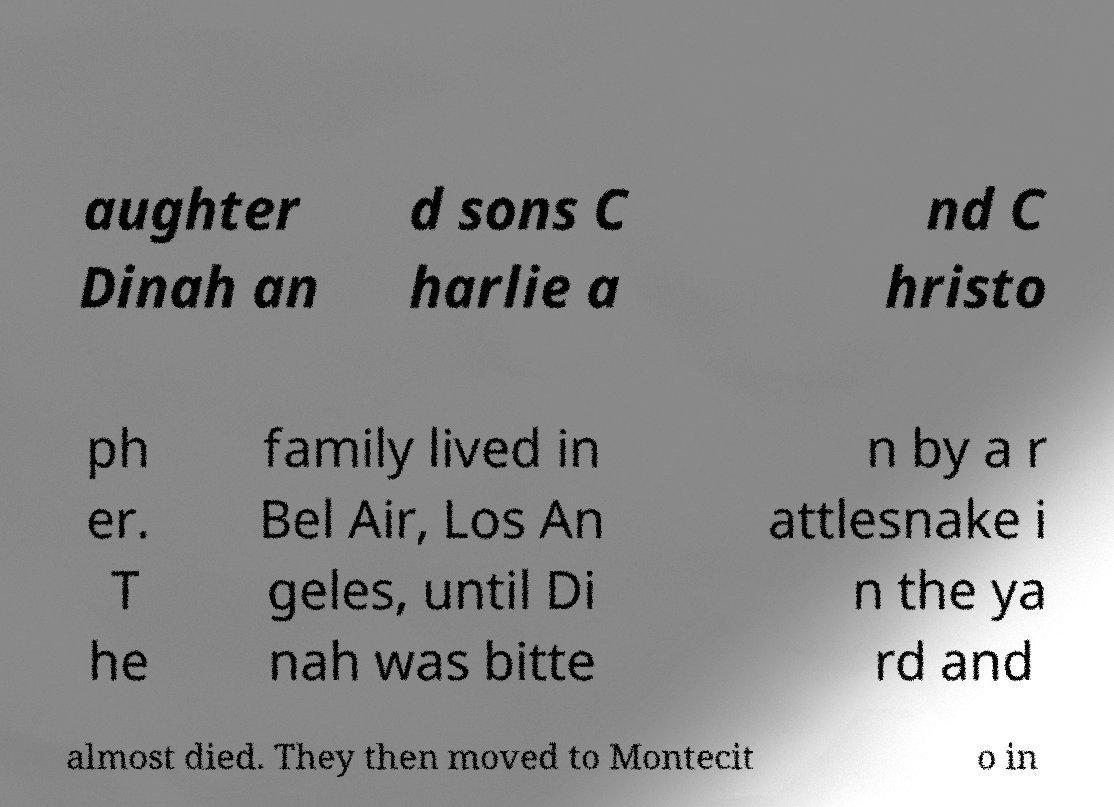There's text embedded in this image that I need extracted. Can you transcribe it verbatim? aughter Dinah an d sons C harlie a nd C hristo ph er. T he family lived in Bel Air, Los An geles, until Di nah was bitte n by a r attlesnake i n the ya rd and almost died. They then moved to Montecit o in 